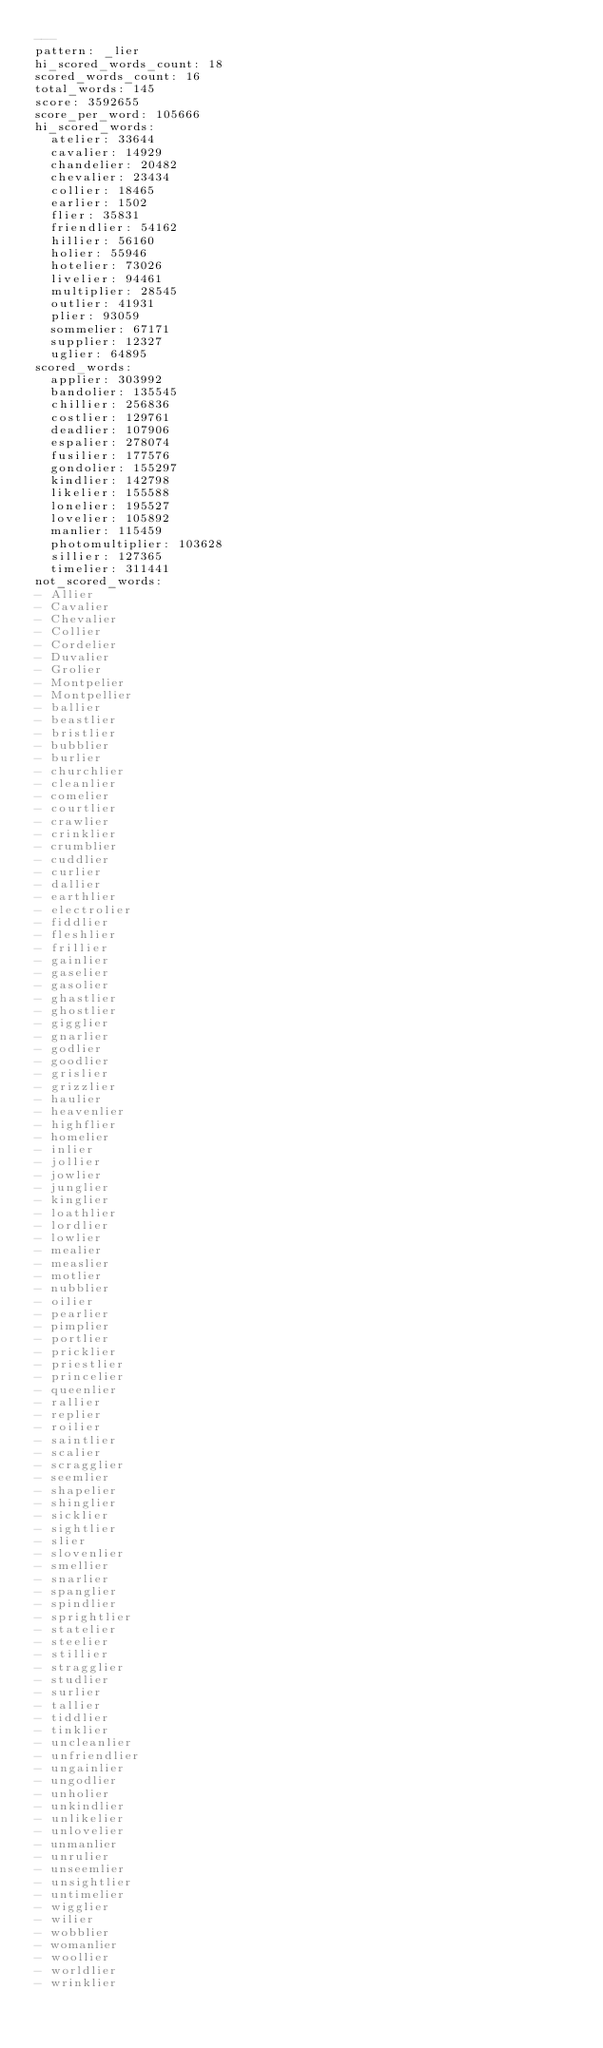<code> <loc_0><loc_0><loc_500><loc_500><_YAML_>---
pattern: _lier
hi_scored_words_count: 18
scored_words_count: 16
total_words: 145
score: 3592655
score_per_word: 105666
hi_scored_words:
  atelier: 33644
  cavalier: 14929
  chandelier: 20482
  chevalier: 23434
  collier: 18465
  earlier: 1502
  flier: 35831
  friendlier: 54162
  hillier: 56160
  holier: 55946
  hotelier: 73026
  livelier: 94461
  multiplier: 28545
  outlier: 41931
  plier: 93059
  sommelier: 67171
  supplier: 12327
  uglier: 64895
scored_words:
  applier: 303992
  bandolier: 135545
  chillier: 256836
  costlier: 129761
  deadlier: 107906
  espalier: 278074
  fusilier: 177576
  gondolier: 155297
  kindlier: 142798
  likelier: 155588
  lonelier: 195527
  lovelier: 105892
  manlier: 115459
  photomultiplier: 103628
  sillier: 127365
  timelier: 311441
not_scored_words:
- Allier
- Cavalier
- Chevalier
- Collier
- Cordelier
- Duvalier
- Grolier
- Montpelier
- Montpellier
- ballier
- beastlier
- bristlier
- bubblier
- burlier
- churchlier
- cleanlier
- comelier
- courtlier
- crawlier
- crinklier
- crumblier
- cuddlier
- curlier
- dallier
- earthlier
- electrolier
- fiddlier
- fleshlier
- frillier
- gainlier
- gaselier
- gasolier
- ghastlier
- ghostlier
- gigglier
- gnarlier
- godlier
- goodlier
- grislier
- grizzlier
- haulier
- heavenlier
- highflier
- homelier
- inlier
- jollier
- jowlier
- junglier
- kinglier
- loathlier
- lordlier
- lowlier
- mealier
- measlier
- motlier
- nubblier
- oilier
- pearlier
- pimplier
- portlier
- pricklier
- priestlier
- princelier
- queenlier
- rallier
- replier
- roilier
- saintlier
- scalier
- scragglier
- seemlier
- shapelier
- shinglier
- sicklier
- sightlier
- slier
- slovenlier
- smellier
- snarlier
- spanglier
- spindlier
- sprightlier
- statelier
- steelier
- stillier
- stragglier
- studlier
- surlier
- tallier
- tiddlier
- tinklier
- uncleanlier
- unfriendlier
- ungainlier
- ungodlier
- unholier
- unkindlier
- unlikelier
- unlovelier
- unmanlier
- unrulier
- unseemlier
- unsightlier
- untimelier
- wigglier
- wilier
- wobblier
- womanlier
- woollier
- worldlier
- wrinklier
</code> 